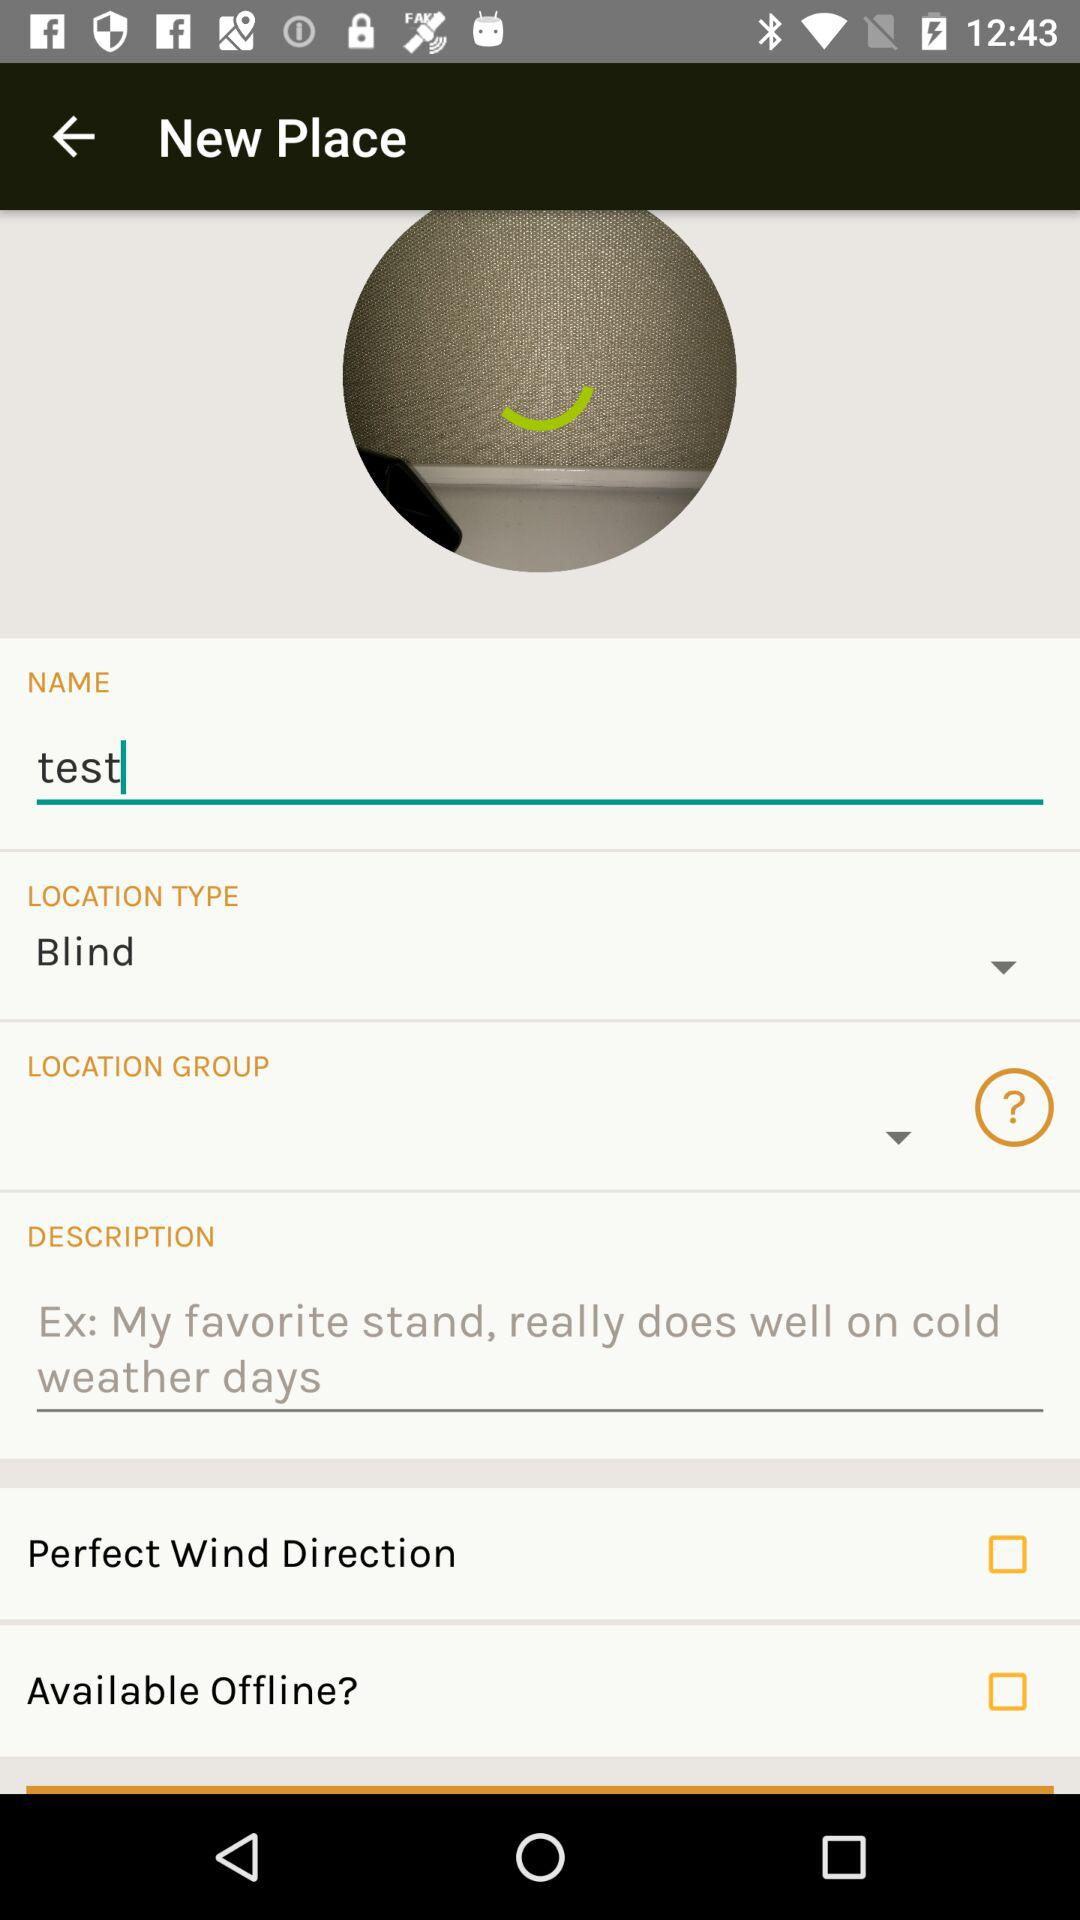Is "Available Offline?" checked or unchecked? "Available Offline?" is unchecked. 